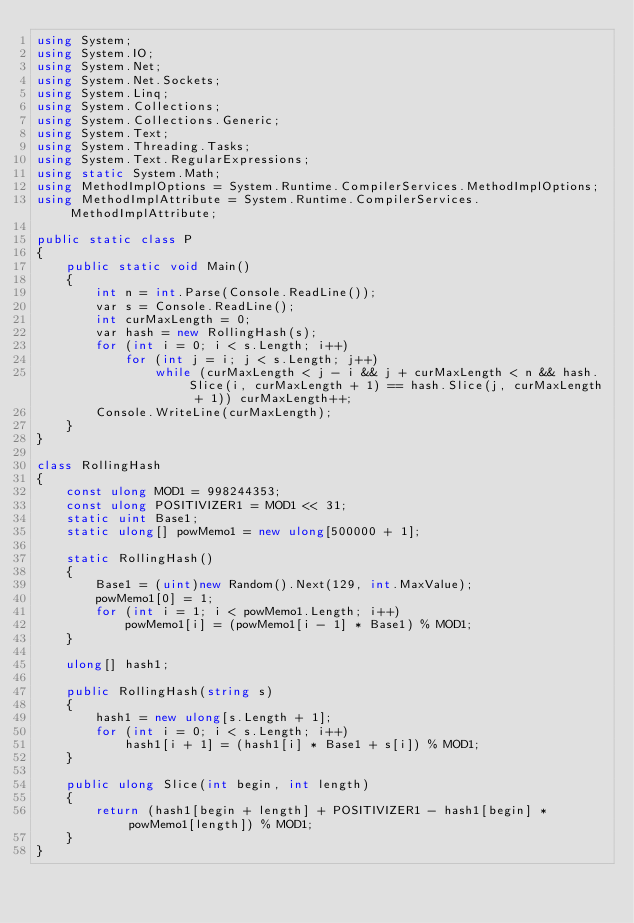Convert code to text. <code><loc_0><loc_0><loc_500><loc_500><_C#_>using System;
using System.IO;
using System.Net;
using System.Net.Sockets;
using System.Linq;
using System.Collections;
using System.Collections.Generic;
using System.Text;
using System.Threading.Tasks;
using System.Text.RegularExpressions;
using static System.Math;
using MethodImplOptions = System.Runtime.CompilerServices.MethodImplOptions;
using MethodImplAttribute = System.Runtime.CompilerServices.MethodImplAttribute;

public static class P
{
    public static void Main()
    {
        int n = int.Parse(Console.ReadLine());
        var s = Console.ReadLine();
        int curMaxLength = 0;
        var hash = new RollingHash(s);
        for (int i = 0; i < s.Length; i++)
            for (int j = i; j < s.Length; j++)
                while (curMaxLength < j - i && j + curMaxLength < n && hash.Slice(i, curMaxLength + 1) == hash.Slice(j, curMaxLength + 1)) curMaxLength++;
        Console.WriteLine(curMaxLength);
    }
}

class RollingHash
{
    const ulong MOD1 = 998244353;
    const ulong POSITIVIZER1 = MOD1 << 31;
    static uint Base1;
    static ulong[] powMemo1 = new ulong[500000 + 1];

    static RollingHash()
    {
        Base1 = (uint)new Random().Next(129, int.MaxValue);
        powMemo1[0] = 1;
        for (int i = 1; i < powMemo1.Length; i++)
            powMemo1[i] = (powMemo1[i - 1] * Base1) % MOD1;
    }

    ulong[] hash1;

    public RollingHash(string s)
    {
        hash1 = new ulong[s.Length + 1];
        for (int i = 0; i < s.Length; i++)
            hash1[i + 1] = (hash1[i] * Base1 + s[i]) % MOD1;
    }

    public ulong Slice(int begin, int length)
    {
        return (hash1[begin + length] + POSITIVIZER1 - hash1[begin] * powMemo1[length]) % MOD1;
    }
}
</code> 